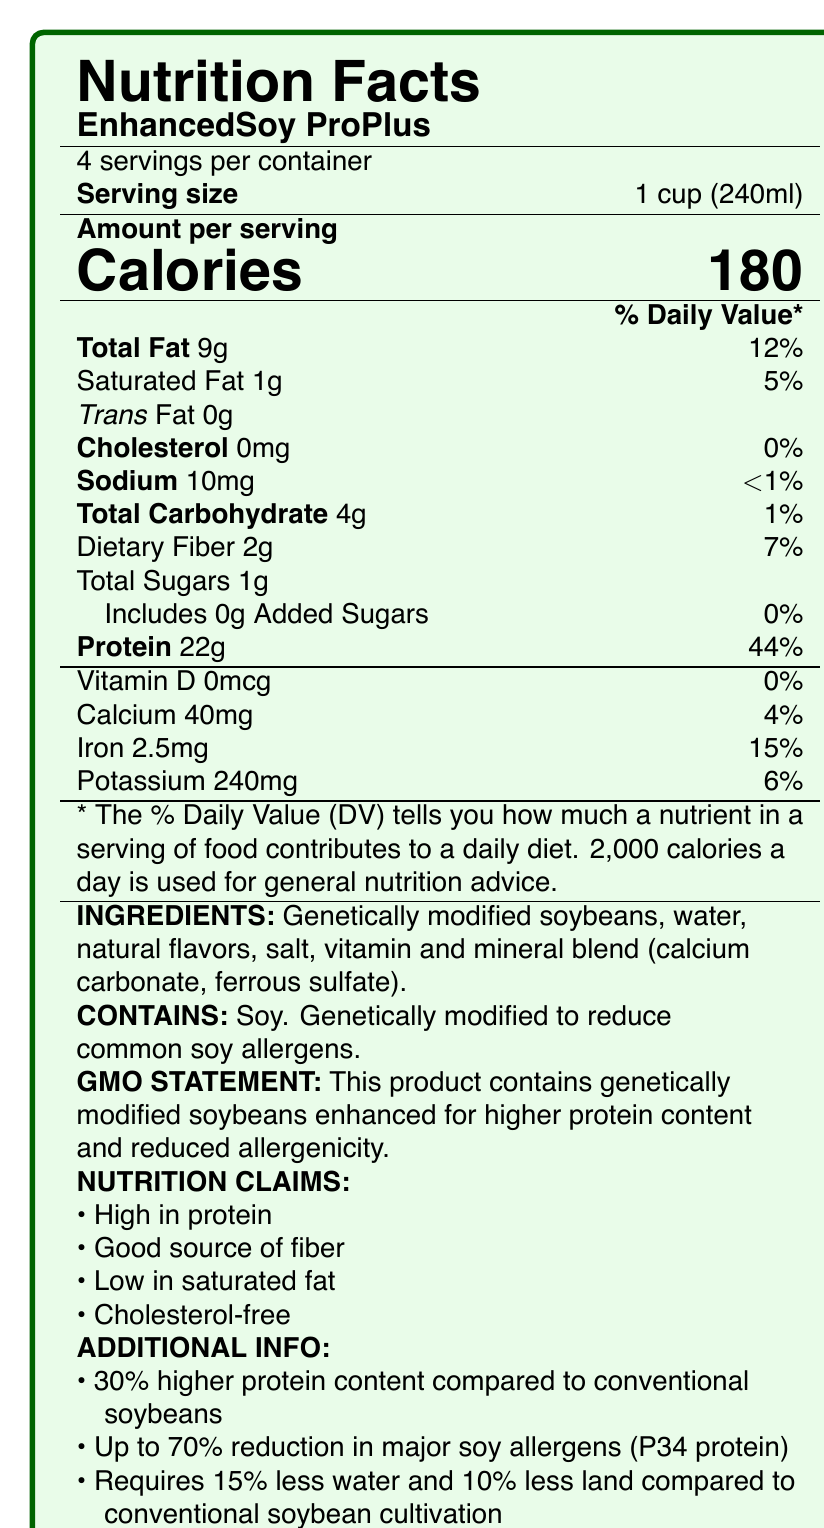what is the serving size of EnhancedSoy ProPlus? The serving size is clearly listed as 1 cup (240ml) on the label.
Answer: 1 cup (240ml) how many servings are in the container? The label states there are 4 servings per container.
Answer: 4 how many grams of total fat does each serving contain? The Total Fat content per serving is listed as 9g.
Answer: 9g what percent of Daily Value of protein does one serving provide? The protein content per serving contributes 44% to the Daily Value.
Answer: 44% what ingredient is high in protein? The label mentions genetically modified soybeans, which are enhanced for higher protein content.
Answer: Genetically modified soybeans which nutrient has the highest Daily Value percent per serving—calcium, iron, or potassium? A. Calcium B. Iron C. Potassium Iron has 15% of the Daily Value per serving, while calcium has 4% and potassium has 6%.
Answer: B. Iron What is reduced in the genetically modified soybeans according to the GMO statement? A. Calories B. Cholesterol C. Allergenicity The GMO statement on the label indicates that the genetically modified soybeans have reduced allergenicity.
Answer: C. Allergenicity Is there any cholesterol in EnhancedSoy ProPlus? The label shows that cholesterol is 0mg, which means it is cholesterol-free.
Answer: No what are the main nutrients EnhancedSoy ProPlus claims to be high in? The nutrition claims on the label state that it is high in protein and a good source of fiber.
Answer: Protein and fiber describe the overall composition and nutritional benefits of EnhancedSoy ProPlus This summary captures the main idea and nutritional advantages of EnhancedSoy ProPlus as provided in the document.
Answer: EnhancedSoy ProPlus is a genetically modified soybean product designed to have higher protein content and reduced allergens. Each serving size is 1 cup (240ml) and contains 180 calories, 9g of total fat, 1g of saturated fat, 0g of trans fat, 0mg cholesterol, 10mg sodium, 4g total carbohydrates, 2g dietary fiber, 1g total sugars, 0g added sugars, and 22g protein. The product provides 44% of the Daily Value of protein, 4% of calcium, 15% of iron, and 6% of potassium per serving. It claims to be high in protein, a good source of fiber, low in saturated fat, and cholesterol-free. It is also more sustainable, requiring less water and land compared to conventional soybeans. what is the sustainability benefit mentioned for EnhancedSoy ProPlus? The label states that it requires 15% less water and 10% less land compared to conventional soybean cultivation.
Answer: Requires 15% less water and 10% less land can you confirm if this product is gluten-free? The document does not provide any information regarding gluten content, so this cannot be determined based on the provided label.
Answer: Not enough information 